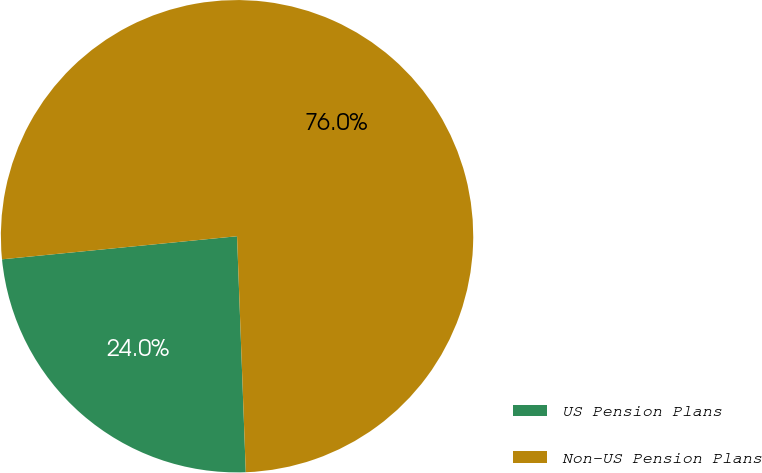Convert chart. <chart><loc_0><loc_0><loc_500><loc_500><pie_chart><fcel>US Pension Plans<fcel>Non-US Pension Plans<nl><fcel>24.03%<fcel>75.97%<nl></chart> 